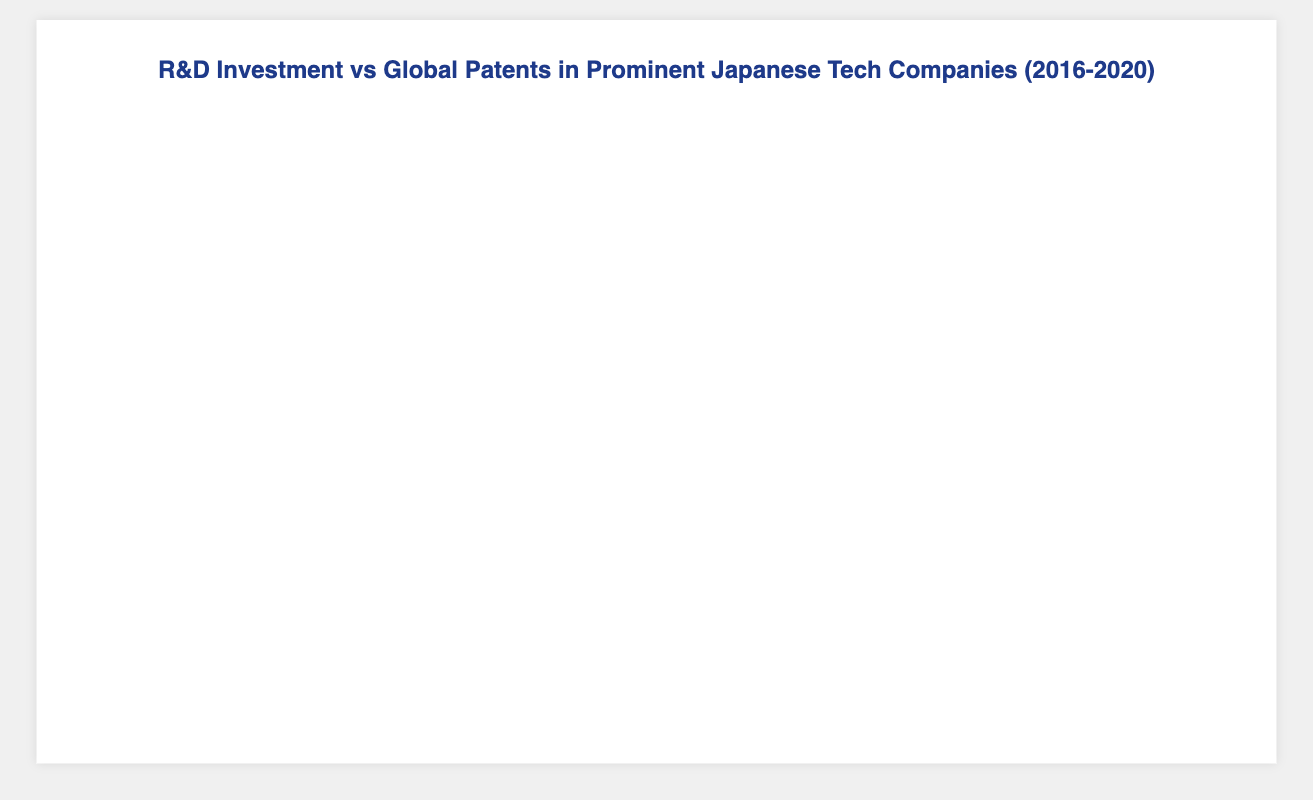What is the title of the figure? The title of the figure is typically found at the top and provides a summary of what the data represents. In this case, it is "R&D Investment vs Global Patents in Prominent Japanese Tech Companies (2016-2020)"
Answer: R&D Investment vs Global Patents in Prominent Japanese Tech Companies (2016-2020) Which company had the highest R&D investment in 2016? By examining the data points for the year 2016, we can see that Sony invested the most in R&D with an investment of 6500 million yen
Answer: Sony How has Sony's R&D investment changed from 2016 to 2020? Looking at the data for Sony from 2016 to 2020, their R&D investment increased each year: 6500 (2016), 6700 (2017), 6900 (2018), 7200 (2019), and 7500 (2020)
Answer: Increased In 2020, which company had more global patents: Fujitsu or Canon? For 2020, we compare the global patents for Fujitsu (2850) and Canon (2700). Fujitsu has more patents
Answer: Fujitsu What was the average R&D investment for Panasonic across all years? Sum Panasonic's investments over the years: 5200 (2016), 5400 (2017), 5600 (2018), 5800 (2019), and 6000 (2020). The total is 28000. The average is 28000/5 = 5600
Answer: 5600 Which company showed the largest increase in global patents from 2016 to 2020? Calculate the increase for each company:
Sony: 3700 - 3100 = 600
Panasonic: 3200 - 2800 = 400
Canon: 2700 - 2400 = 300
Fujitsu: 2850 - 2600 = 250
Hitachi: 2900 - 2700 = 200
Sony had the largest increase with 600 patents
Answer: Sony How does the trend of R&D investment over the years compare between Sony and Hitachi? Examine the data to observe trends: Sony's R&D investments were consistently increasing each year from 6500 to 7500, while Hitachi also showed an upward trend but with smaller increments from 4900 to 5500
Answer: Both increased, Sony's increase was larger What is the total number of global patents for Fujitsu over the presented years? Sum up the global patents for Fujitsu from 2016 to 2020: 2600 + 2650 + 2700 + 2750 + 2850 = 13550
Answer: 13550 Considering all companies, which year had the highest total R&D investment? Calculate the total R&D investment for each year:
2016: 6500 + 5200 + 3700 + 4500 + 4900 = 24800
2017: 6700 + 5400 + 3800 + 4600 + 5050 = 25550
2018: 6900 + 5600 + 3900 + 4700 + 5200 = 26300
2019: 7200 + 5800 + 4000 + 4850 + 5350 = 27200
2020: 7500 + 6000 + 4150 + 5000 + 5500 = 28150
2020 had the highest total R&D investment with 28150 million yen
Answer: 2020 